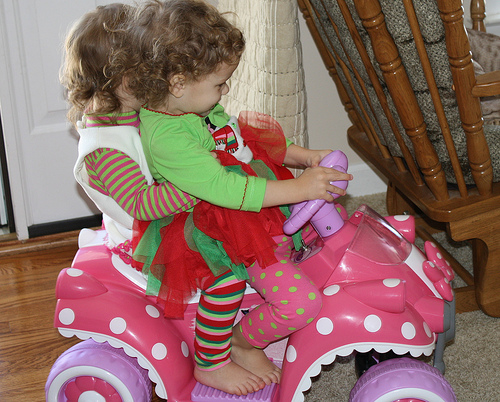<image>
Is the bow above the bar? Yes. The bow is positioned above the bar in the vertical space, higher up in the scene. 